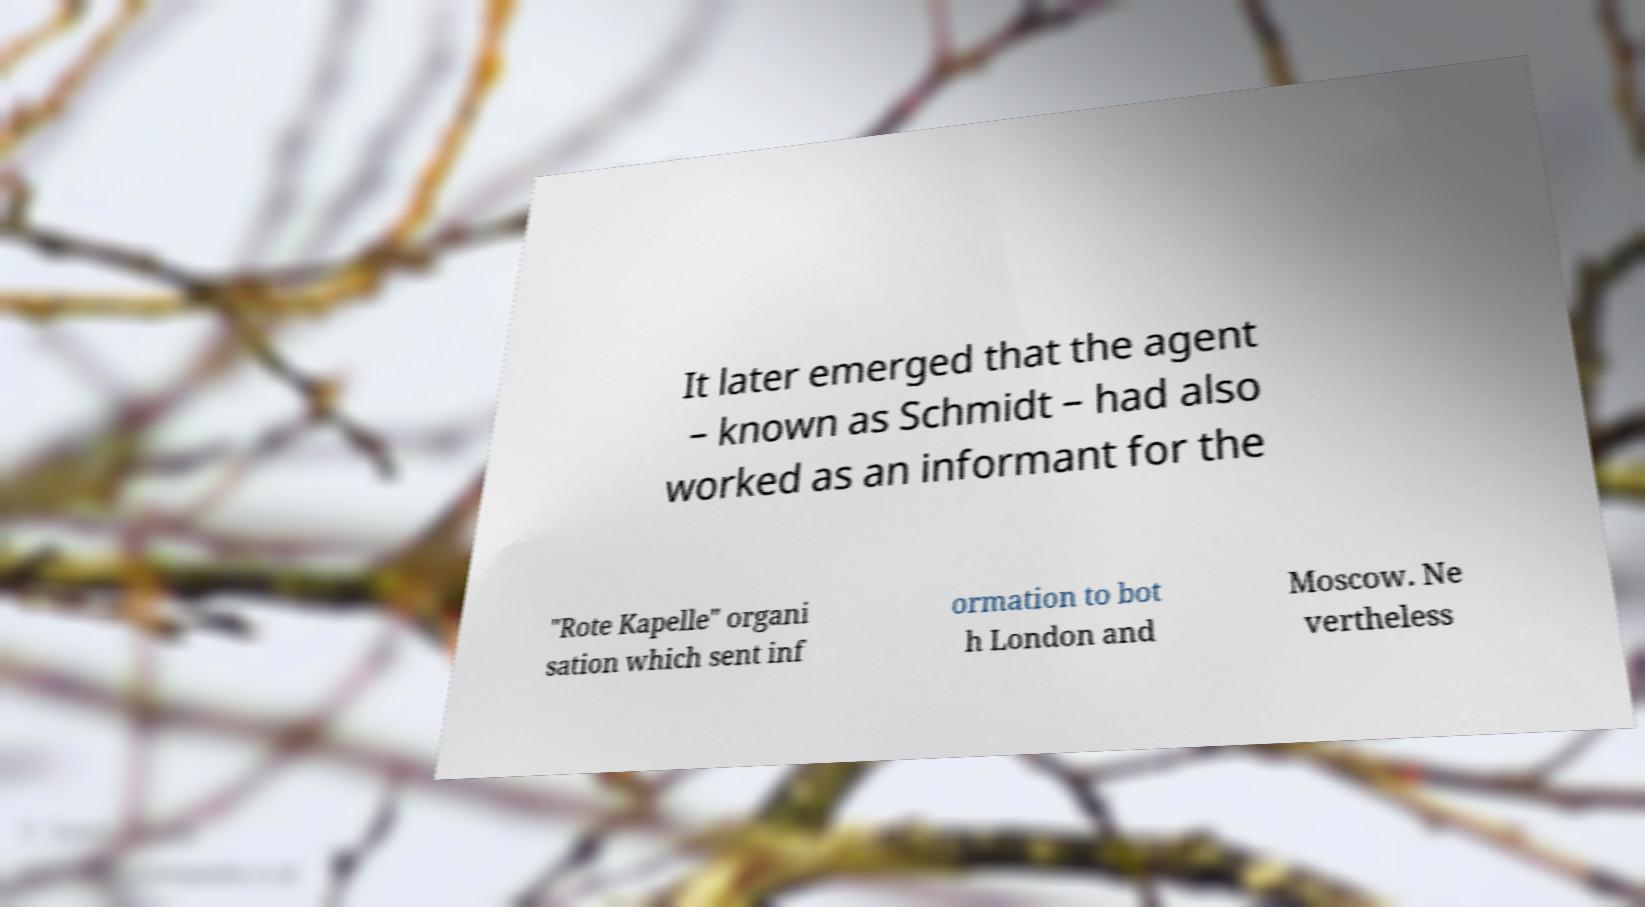There's text embedded in this image that I need extracted. Can you transcribe it verbatim? It later emerged that the agent – known as Schmidt – had also worked as an informant for the "Rote Kapelle" organi sation which sent inf ormation to bot h London and Moscow. Ne vertheless 